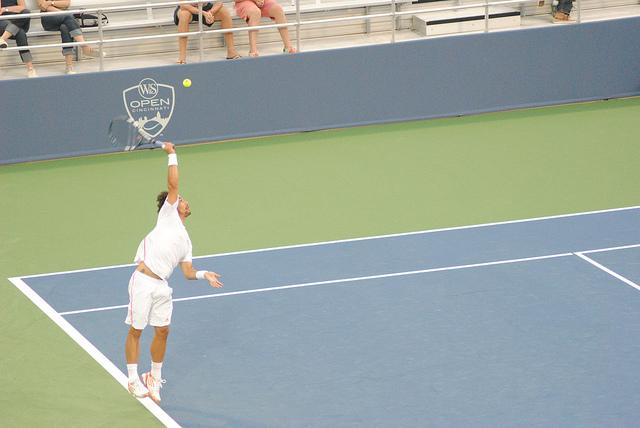What does the W S stand for? Please explain your reasoning. western/southern. The ws is for directions. 